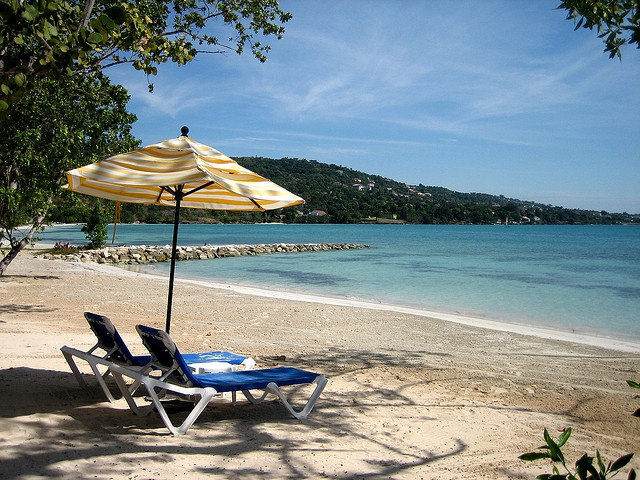Describe the objects in this image and their specific colors. I can see umbrella in black, ivory, olive, tan, and khaki tones, chair in black, gray, navy, and darkgray tones, and chair in black, gray, and ivory tones in this image. 